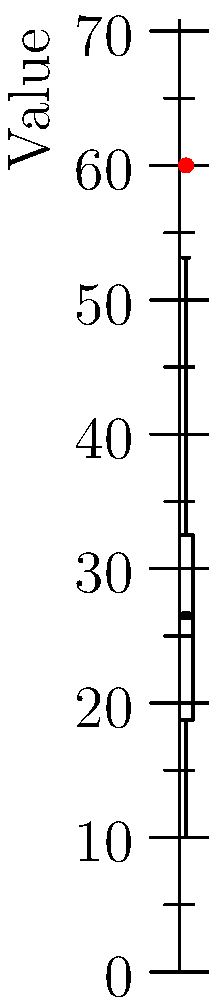Given the box plot representing a dataset, how many outliers are present, and what is the value of the most extreme outlier? To identify outliers and find the most extreme one, follow these steps:

1. Understand the box plot components:
   - The box represents the interquartile range (IQR) from Q1 to Q3
   - The line inside the box is the median
   - The whiskers extend to the minimum and maximum values within 1.5 * IQR from Q1 and Q3

2. Identify the outliers:
   - Outliers are points that fall beyond the whiskers
   - In this plot, we can see two red dots representing outliers

3. Determine the number of outliers:
   - Count the red dots: there are 2 outliers

4. Find the most extreme outlier:
   - The outlier furthest from the box is the most extreme
   - In this case, it's the highest point on the plot

5. Estimate the value of the most extreme outlier:
   - The y-axis shows that the highest point is at approximately 60

Therefore, there are 2 outliers, and the most extreme outlier has a value of approximately 60.
Answer: 2 outliers; most extreme value ≈ 60 